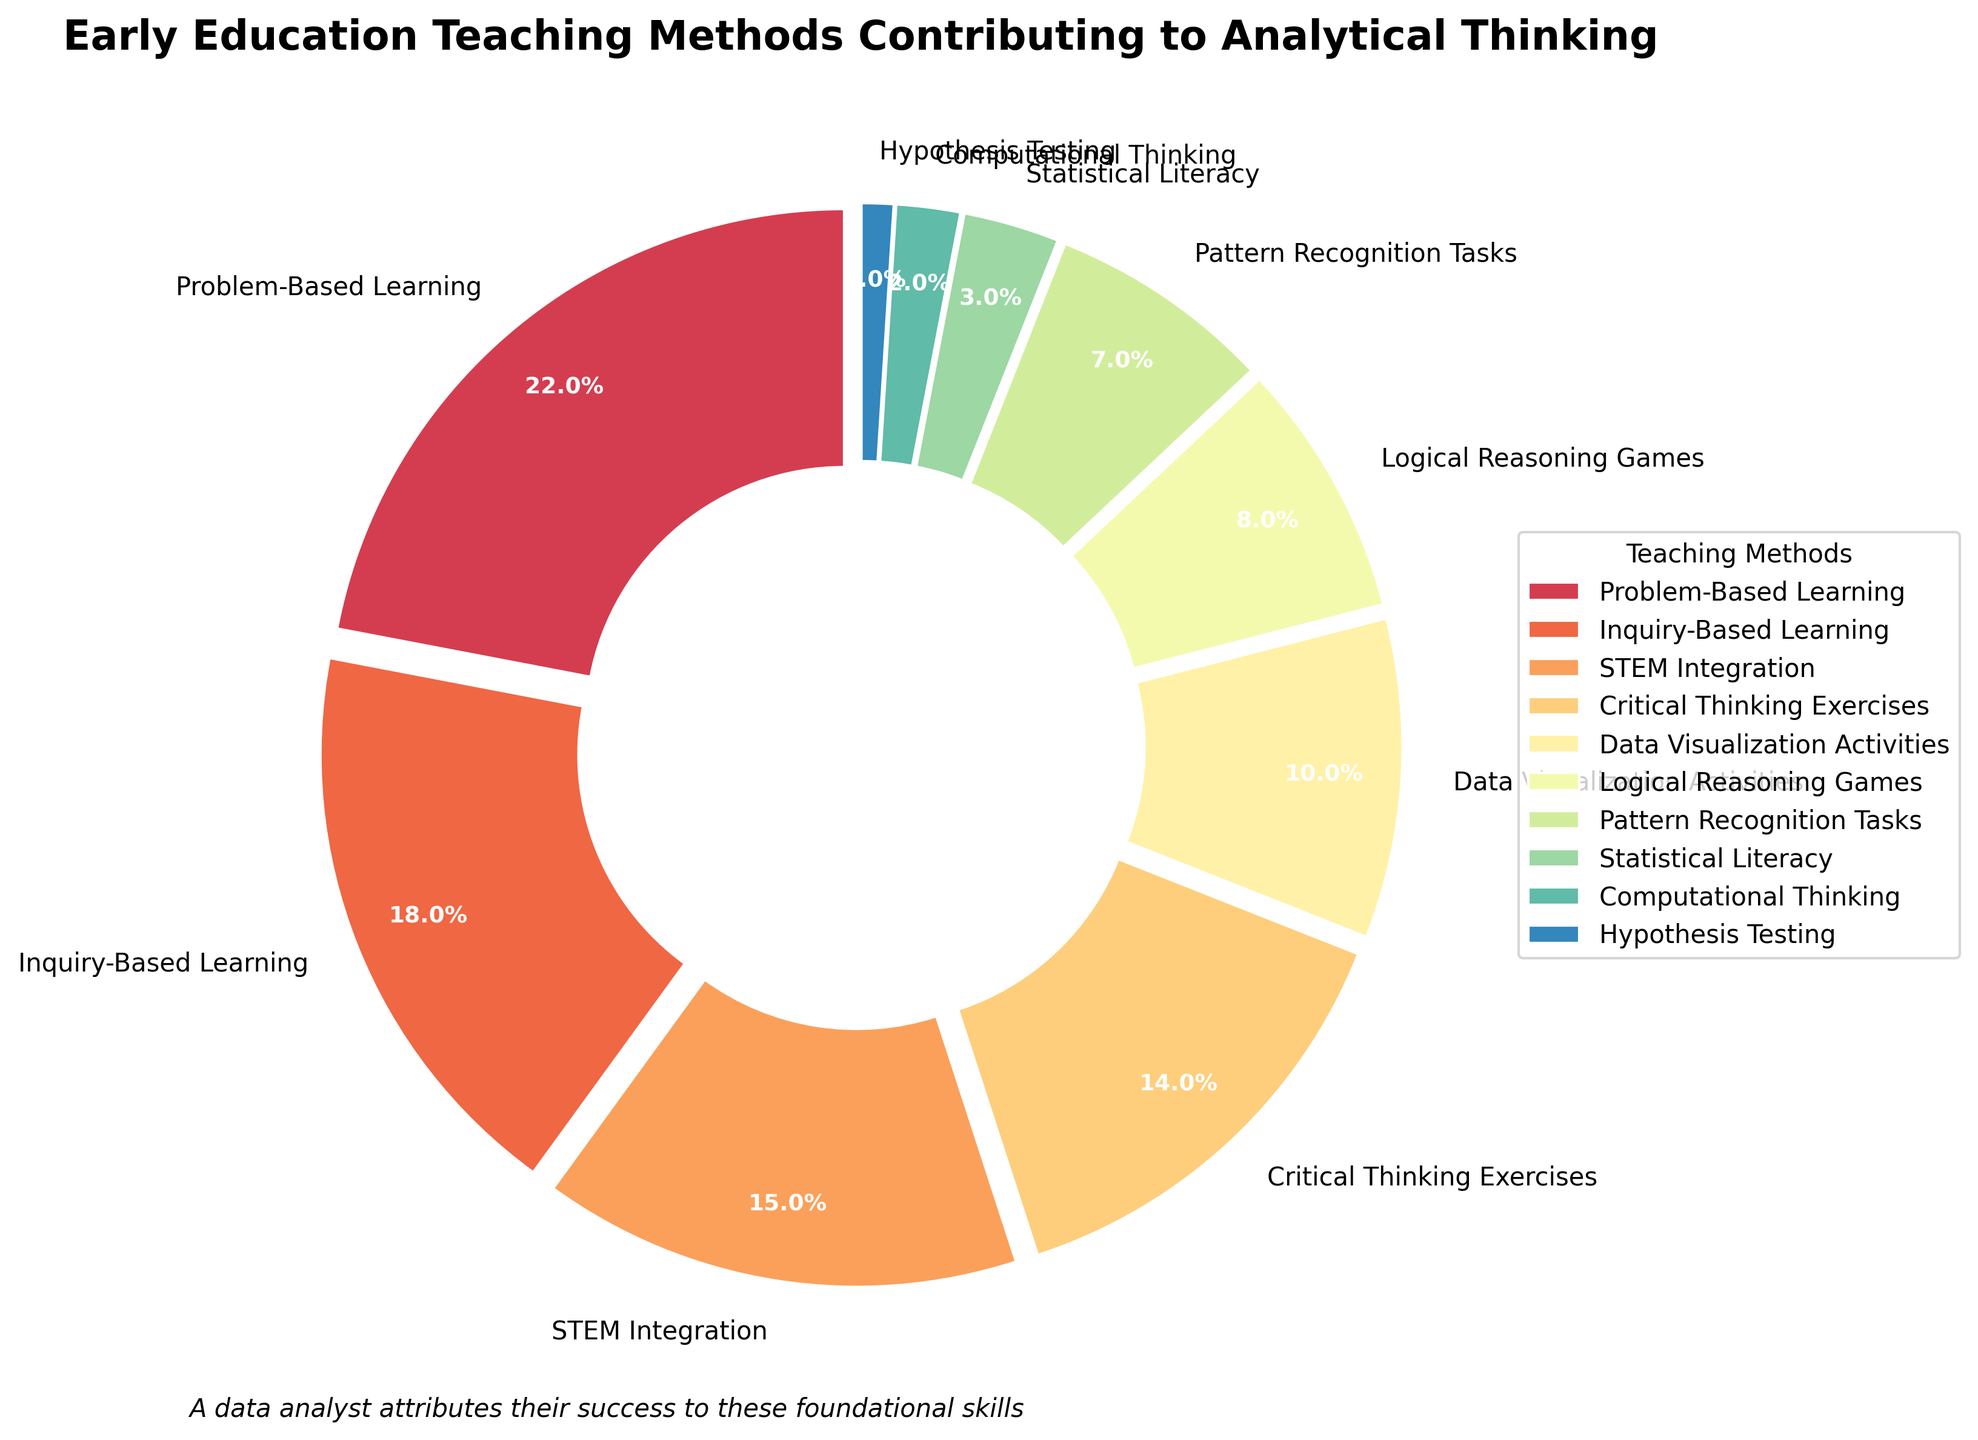What percentage of teaching methods is attributed to Problem-Based Learning? The percentage of Problem-Based Learning is directly labeled in the pie chart.
Answer: 22% Which teaching method contributes the least to analytical thinking? Identify the teaching method with the smallest percentage from the pie chart.
Answer: Hypothesis Testing What is the combined percentage of Critical Thinking Exercises, Logical Reasoning Games, and Statistical Literacy? Sum the percentages: Critical Thinking Exercises (14%), Logical Reasoning Games (8%), and Statistical Literacy (3%). 14% + 8% + 3% = 25%.
Answer: 25% Which teaching method contributes more to analytical thinking, STEM Integration or Data Visualization Activities? Compare the percentages of STEM Integration (15%) and Data Visualization Activities (10%). STEM Integration has a higher percentage.
Answer: STEM Integration How many teaching methods have a percentage greater than 10%? Identify and count the teaching methods with percentages greater than 10%: Problem-Based Learning (22%), Inquiry-Based Learning (18%), STEM Integration (15%), Critical Thinking Exercises (14%). The count is 4.
Answer: 4 What is the difference in contribution between Inquiry-Based Learning and Problem-Based Learning? Subtract the percentage of Problem-Based Learning (22%) from Inquiry-Based Learning (18%). 22% - 18% = 4%.
Answer: 4% Which teaching method is represented by the largest wedge in the pie chart? Identify the wedge with the largest size based on the percentage. Problem-Based Learning has the highest percentage (22%).
Answer: Problem-Based Learning What is the summed percentage of the three teaching methods with the lowest contributions? Sum the percentages of the three smallest contributions: Hypothesis Testing (1%), Computational Thinking (2%), Statistical Literacy (3%). 1% + 2% + 3% = 6%.
Answer: 6% Is Pattern Recognition Tasks' percentage closer to 5% or 10%? Determine which value (5% or 10%) is closer to Pattern Recognition Tasks' percentage (7%). 7% is closer to 5% than to 10%.
Answer: 5% By how much does Data Visualization Activities' contribution exceed Logical Reasoning Games'? Subtract the percentage of Logical Reasoning Games (8%) from Data Visualization Activities (10%). 10% - 8% = 2%.
Answer: 2% 